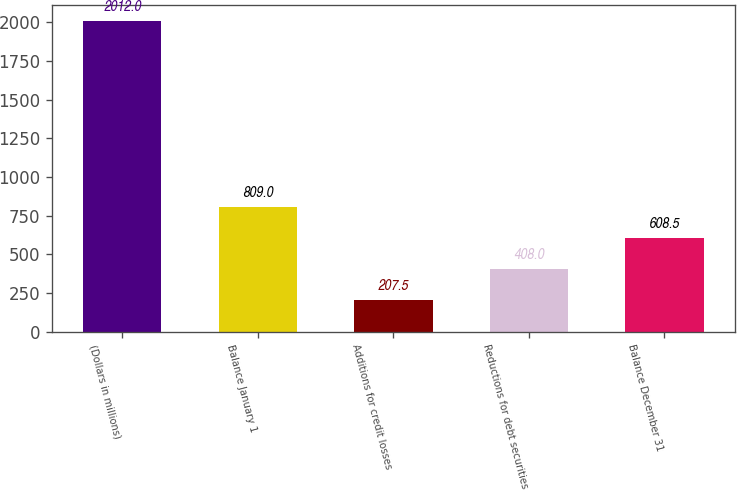<chart> <loc_0><loc_0><loc_500><loc_500><bar_chart><fcel>(Dollars in millions)<fcel>Balance January 1<fcel>Additions for credit losses<fcel>Reductions for debt securities<fcel>Balance December 31<nl><fcel>2012<fcel>809<fcel>207.5<fcel>408<fcel>608.5<nl></chart> 